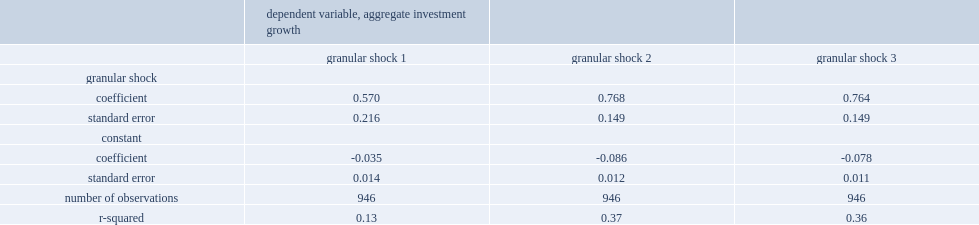What is the range of annual industry-level variation that granular shocks can explain? 0.13 0.37. 